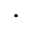Convert formula to latex. <formula><loc_0><loc_0><loc_500><loc_500>\cdot</formula> 